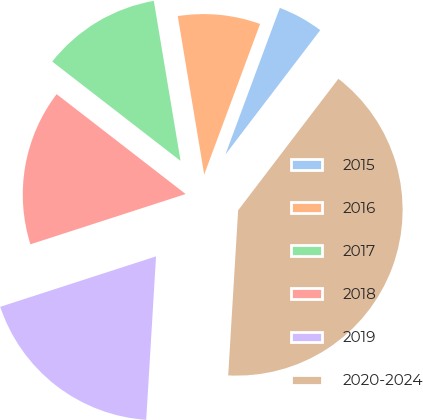Convert chart to OTSL. <chart><loc_0><loc_0><loc_500><loc_500><pie_chart><fcel>2015<fcel>2016<fcel>2017<fcel>2018<fcel>2019<fcel>2020-2024<nl><fcel>4.71%<fcel>8.29%<fcel>11.88%<fcel>15.47%<fcel>19.06%<fcel>40.59%<nl></chart> 